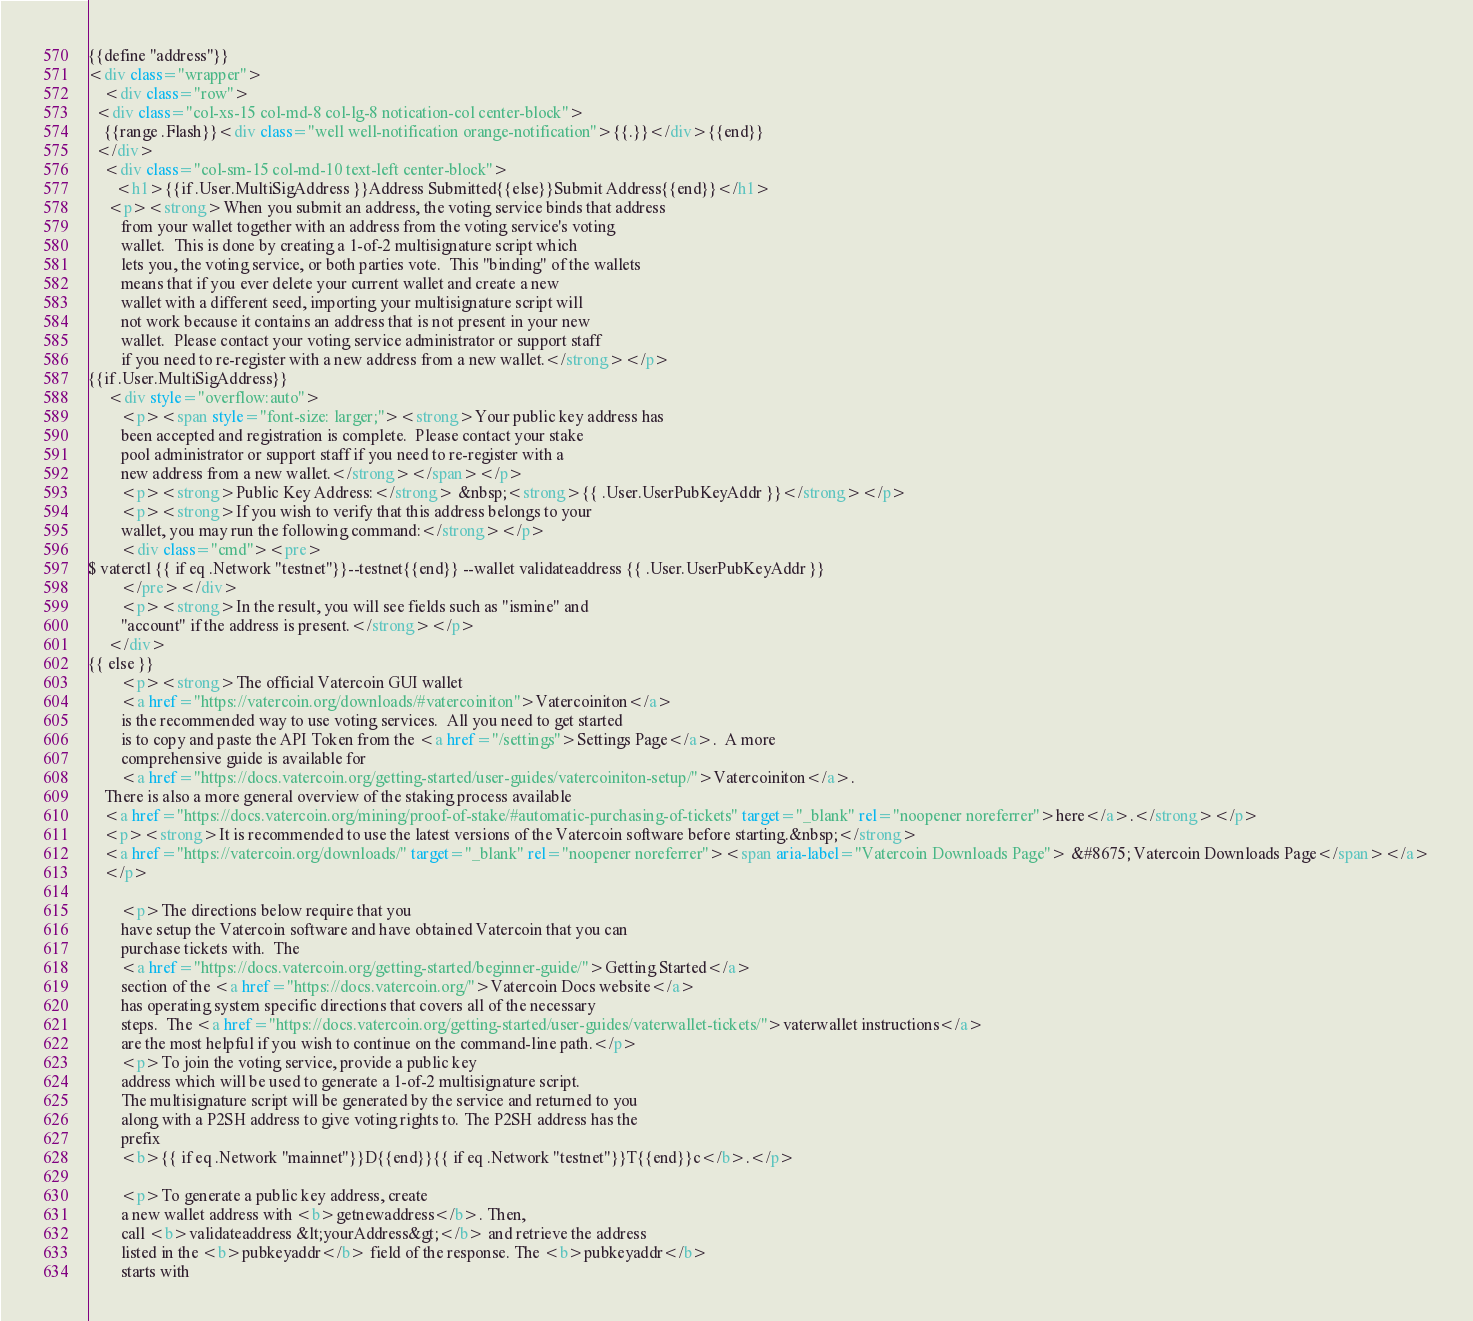Convert code to text. <code><loc_0><loc_0><loc_500><loc_500><_HTML_>{{define "address"}}
<div class="wrapper">
    <div class="row">
  <div class="col-xs-15 col-md-8 col-lg-8 notication-col center-block">
    {{range .Flash}}<div class="well well-notification orange-notification">{{.}}</div>{{end}}
  </div>
    <div class="col-sm-15 col-md-10 text-left center-block">
       <h1>{{if .User.MultiSigAddress }}Address Submitted{{else}}Submit Address{{end}}</h1>
     <p><strong>When you submit an address, the voting service binds that address
        from your wallet together with an address from the voting service's voting
        wallet.  This is done by creating a 1-of-2 multisignature script which
        lets you, the voting service, or both parties vote.  This "binding" of the wallets
        means that if you ever delete your current wallet and create a new
        wallet with a different seed, importing your multisignature script will
        not work because it contains an address that is not present in your new
        wallet.  Please contact your voting service administrator or support staff
        if you need to re-register with a new address from a new wallet.</strong></p>
{{if .User.MultiSigAddress}}
     <div style="overflow:auto">
        <p><span style="font-size: larger;"><strong>Your public key address has
        been accepted and registration is complete.  Please contact your stake
        pool administrator or support staff if you need to re-register with a
        new address from a new wallet.</strong></span></p>
        <p><strong>Public Key Address:</strong> &nbsp;<strong>{{ .User.UserPubKeyAddr }}</strong></p>
        <p><strong>If you wish to verify that this address belongs to your
        wallet, you may run the following command:</strong></p>
        <div class="cmd"><pre>
$ vaterctl {{ if eq .Network "testnet"}}--testnet{{end}} --wallet validateaddress {{ .User.UserPubKeyAddr }}
        </pre></div>
        <p><strong>In the result, you will see fields such as "ismine" and
        "account" if the address is present.</strong></p>
     </div>
{{ else }}
        <p><strong>The official Vatercoin GUI wallet
        <a href="https://vatercoin.org/downloads/#vatercoiniton">Vatercoiniton</a>
        is the recommended way to use voting services.  All you need to get started
        is to copy and paste the API Token from the <a href="/settings">Settings Page</a>.  A more
        comprehensive guide is available for
        <a href="https://docs.vatercoin.org/getting-started/user-guides/vatercoiniton-setup/">Vatercoiniton</a>.
	There is also a more general overview of the staking process available
	<a href="https://docs.vatercoin.org/mining/proof-of-stake/#automatic-purchasing-of-tickets" target="_blank" rel="noopener noreferrer">here</a>.</strong></p>
	<p><strong>It is recommended to use the latest versions of the Vatercoin software before starting.&nbsp;</strong>
	<a href="https://vatercoin.org/downloads/" target="_blank" rel="noopener noreferrer"><span aria-label="Vatercoin Downloads Page"> &#8675; Vatercoin Downloads Page</span></a>
	</p>

        <p>The directions below require that you
        have setup the Vatercoin software and have obtained Vatercoin that you can
        purchase tickets with.  The
        <a href="https://docs.vatercoin.org/getting-started/beginner-guide/">Getting Started</a>
        section of the <a href="https://docs.vatercoin.org/">Vatercoin Docs website</a>
        has operating system specific directions that covers all of the necessary
        steps.  The <a href="https://docs.vatercoin.org/getting-started/user-guides/vaterwallet-tickets/">vaterwallet instructions</a>
        are the most helpful if you wish to continue on the command-line path.</p>
        <p>To join the voting service, provide a public key
        address which will be used to generate a 1-of-2 multisignature script.
        The multisignature script will be generated by the service and returned to you
        along with a P2SH address to give voting rights to. The P2SH address has the
        prefix
        <b>{{ if eq .Network "mainnet"}}D{{end}}{{ if eq .Network "testnet"}}T{{end}}c</b>.</p>

        <p>To generate a public key address, create
        a new wallet address with <b>getnewaddress</b>. Then,
        call <b>validateaddress &lt;yourAddress&gt;</b> and retrieve the address
        listed in the <b>pubkeyaddr</b> field of the response. The <b>pubkeyaddr</b>
        starts with</code> 